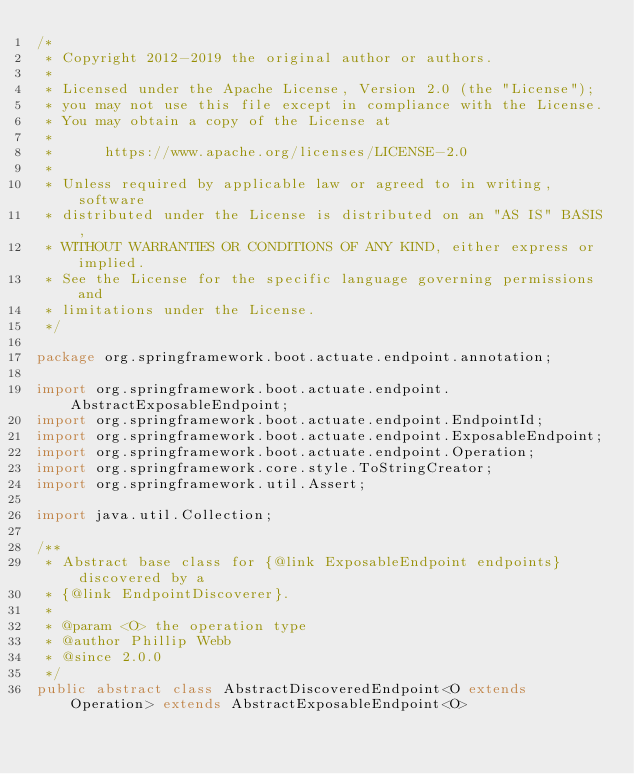Convert code to text. <code><loc_0><loc_0><loc_500><loc_500><_Java_>/*
 * Copyright 2012-2019 the original author or authors.
 *
 * Licensed under the Apache License, Version 2.0 (the "License");
 * you may not use this file except in compliance with the License.
 * You may obtain a copy of the License at
 *
 *      https://www.apache.org/licenses/LICENSE-2.0
 *
 * Unless required by applicable law or agreed to in writing, software
 * distributed under the License is distributed on an "AS IS" BASIS,
 * WITHOUT WARRANTIES OR CONDITIONS OF ANY KIND, either express or implied.
 * See the License for the specific language governing permissions and
 * limitations under the License.
 */

package org.springframework.boot.actuate.endpoint.annotation;

import org.springframework.boot.actuate.endpoint.AbstractExposableEndpoint;
import org.springframework.boot.actuate.endpoint.EndpointId;
import org.springframework.boot.actuate.endpoint.ExposableEndpoint;
import org.springframework.boot.actuate.endpoint.Operation;
import org.springframework.core.style.ToStringCreator;
import org.springframework.util.Assert;

import java.util.Collection;

/**
 * Abstract base class for {@link ExposableEndpoint endpoints} discovered by a
 * {@link EndpointDiscoverer}.
 *
 * @param <O> the operation type
 * @author Phillip Webb
 * @since 2.0.0
 */
public abstract class AbstractDiscoveredEndpoint<O extends Operation> extends AbstractExposableEndpoint<O></code> 